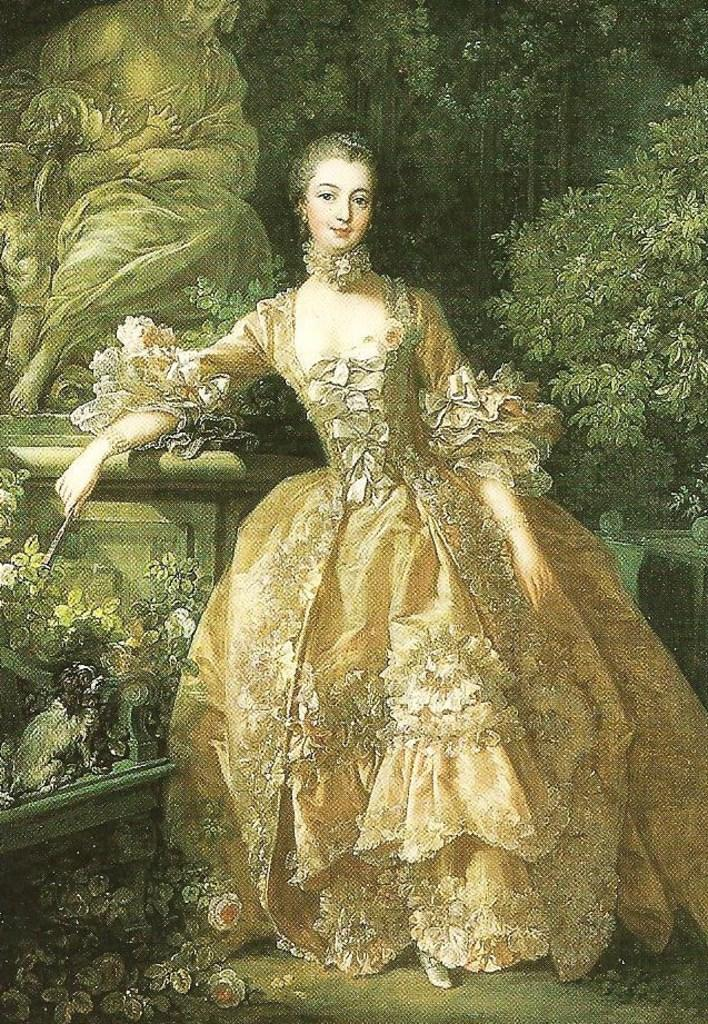What is the main subject of the image? There is a painting in the image. What is the central figure in the painting? The painting features a woman in the middle. What can be seen in the background of the painting? In the background of the painting, there are plants and a person depicted. What type of beef is being served in the painting? There is no beef present in the painting; it features a woman, plants, and another person in the background. 